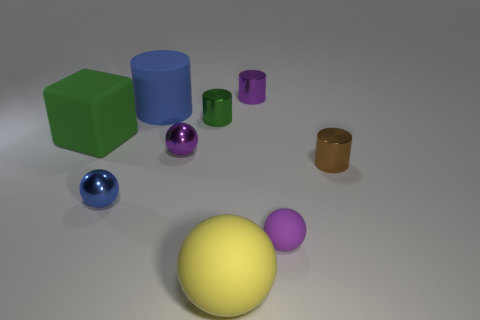Are there any other things that are the same color as the block?
Offer a very short reply. Yes. There is a purple metal cylinder; does it have the same size as the ball behind the tiny blue ball?
Make the answer very short. Yes. How many tiny things are either purple spheres or yellow rubber things?
Offer a terse response. 2. Are there more yellow matte spheres than large blue metallic spheres?
Make the answer very short. Yes. There is a large object that is on the right side of the small purple metallic thing that is in front of the large cube; how many tiny balls are left of it?
Offer a terse response. 2. What is the shape of the yellow rubber object?
Provide a succinct answer. Sphere. How many other objects are the same material as the large yellow ball?
Make the answer very short. 3. Is the blue metal sphere the same size as the green shiny cylinder?
Offer a terse response. Yes. What shape is the blue thing that is left of the blue cylinder?
Offer a terse response. Sphere. The small shiny cylinder on the left side of the metal cylinder that is behind the small green object is what color?
Your response must be concise. Green. 